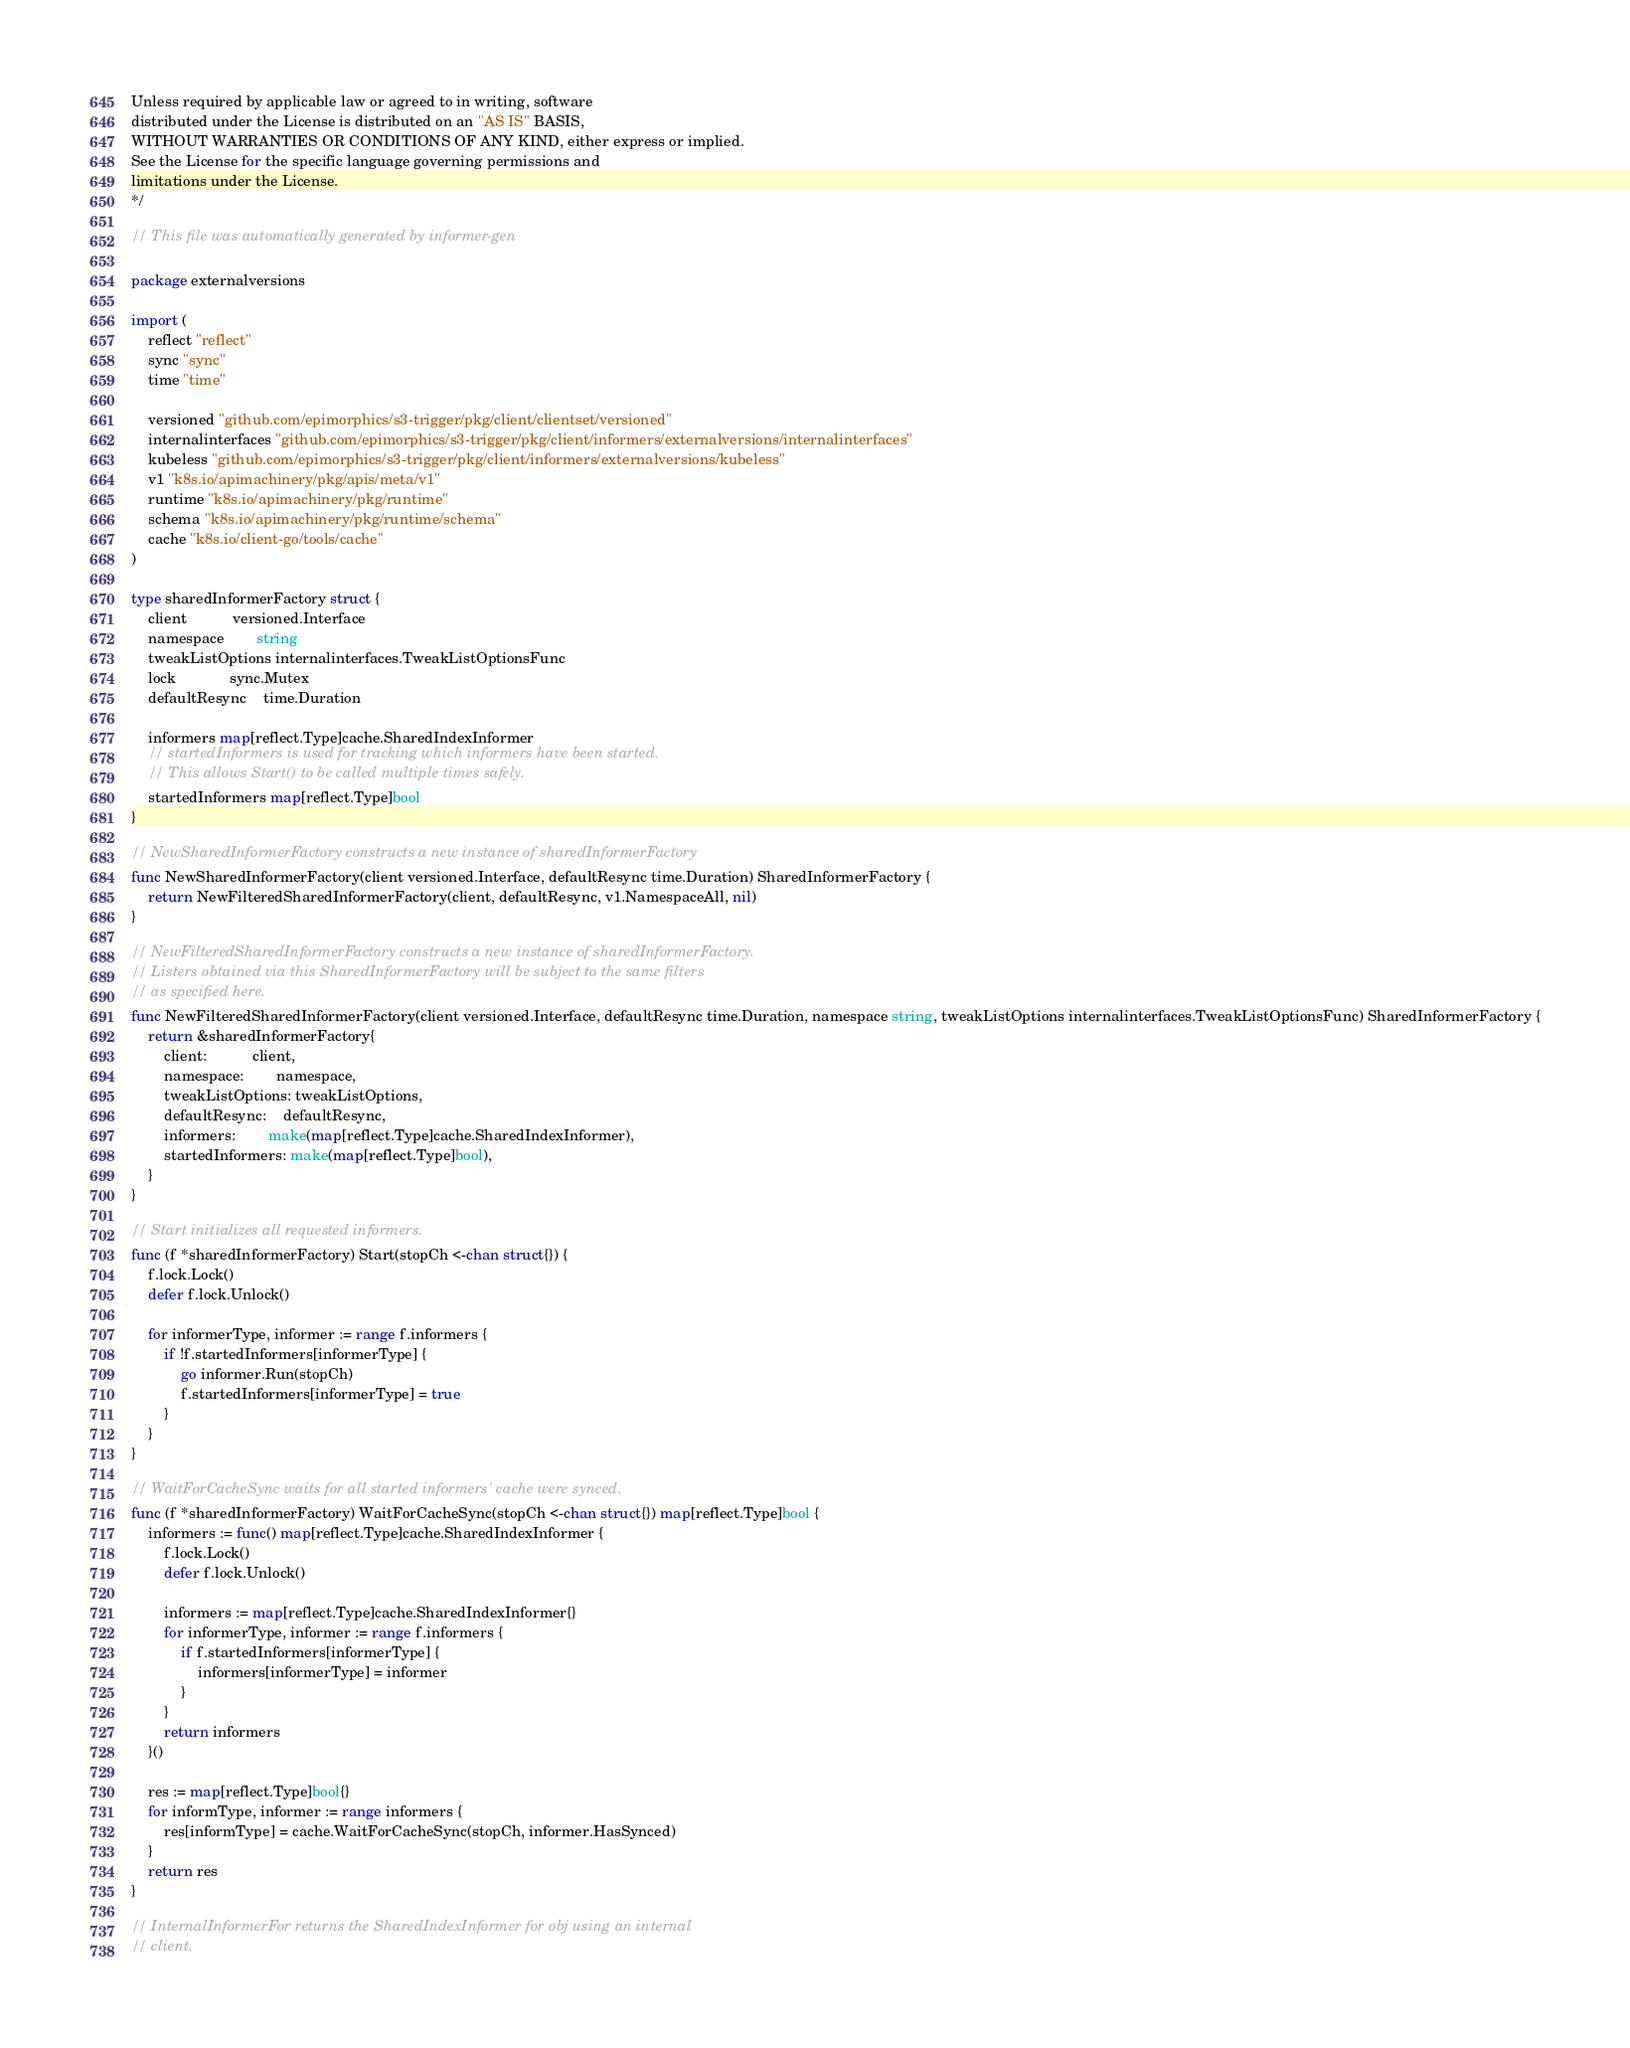<code> <loc_0><loc_0><loc_500><loc_500><_Go_>Unless required by applicable law or agreed to in writing, software
distributed under the License is distributed on an "AS IS" BASIS,
WITHOUT WARRANTIES OR CONDITIONS OF ANY KIND, either express or implied.
See the License for the specific language governing permissions and
limitations under the License.
*/

// This file was automatically generated by informer-gen

package externalversions

import (
	reflect "reflect"
	sync "sync"
	time "time"

	versioned "github.com/epimorphics/s3-trigger/pkg/client/clientset/versioned"
	internalinterfaces "github.com/epimorphics/s3-trigger/pkg/client/informers/externalversions/internalinterfaces"
	kubeless "github.com/epimorphics/s3-trigger/pkg/client/informers/externalversions/kubeless"
	v1 "k8s.io/apimachinery/pkg/apis/meta/v1"
	runtime "k8s.io/apimachinery/pkg/runtime"
	schema "k8s.io/apimachinery/pkg/runtime/schema"
	cache "k8s.io/client-go/tools/cache"
)

type sharedInformerFactory struct {
	client           versioned.Interface
	namespace        string
	tweakListOptions internalinterfaces.TweakListOptionsFunc
	lock             sync.Mutex
	defaultResync    time.Duration

	informers map[reflect.Type]cache.SharedIndexInformer
	// startedInformers is used for tracking which informers have been started.
	// This allows Start() to be called multiple times safely.
	startedInformers map[reflect.Type]bool
}

// NewSharedInformerFactory constructs a new instance of sharedInformerFactory
func NewSharedInformerFactory(client versioned.Interface, defaultResync time.Duration) SharedInformerFactory {
	return NewFilteredSharedInformerFactory(client, defaultResync, v1.NamespaceAll, nil)
}

// NewFilteredSharedInformerFactory constructs a new instance of sharedInformerFactory.
// Listers obtained via this SharedInformerFactory will be subject to the same filters
// as specified here.
func NewFilteredSharedInformerFactory(client versioned.Interface, defaultResync time.Duration, namespace string, tweakListOptions internalinterfaces.TweakListOptionsFunc) SharedInformerFactory {
	return &sharedInformerFactory{
		client:           client,
		namespace:        namespace,
		tweakListOptions: tweakListOptions,
		defaultResync:    defaultResync,
		informers:        make(map[reflect.Type]cache.SharedIndexInformer),
		startedInformers: make(map[reflect.Type]bool),
	}
}

// Start initializes all requested informers.
func (f *sharedInformerFactory) Start(stopCh <-chan struct{}) {
	f.lock.Lock()
	defer f.lock.Unlock()

	for informerType, informer := range f.informers {
		if !f.startedInformers[informerType] {
			go informer.Run(stopCh)
			f.startedInformers[informerType] = true
		}
	}
}

// WaitForCacheSync waits for all started informers' cache were synced.
func (f *sharedInformerFactory) WaitForCacheSync(stopCh <-chan struct{}) map[reflect.Type]bool {
	informers := func() map[reflect.Type]cache.SharedIndexInformer {
		f.lock.Lock()
		defer f.lock.Unlock()

		informers := map[reflect.Type]cache.SharedIndexInformer{}
		for informerType, informer := range f.informers {
			if f.startedInformers[informerType] {
				informers[informerType] = informer
			}
		}
		return informers
	}()

	res := map[reflect.Type]bool{}
	for informType, informer := range informers {
		res[informType] = cache.WaitForCacheSync(stopCh, informer.HasSynced)
	}
	return res
}

// InternalInformerFor returns the SharedIndexInformer for obj using an internal
// client.</code> 